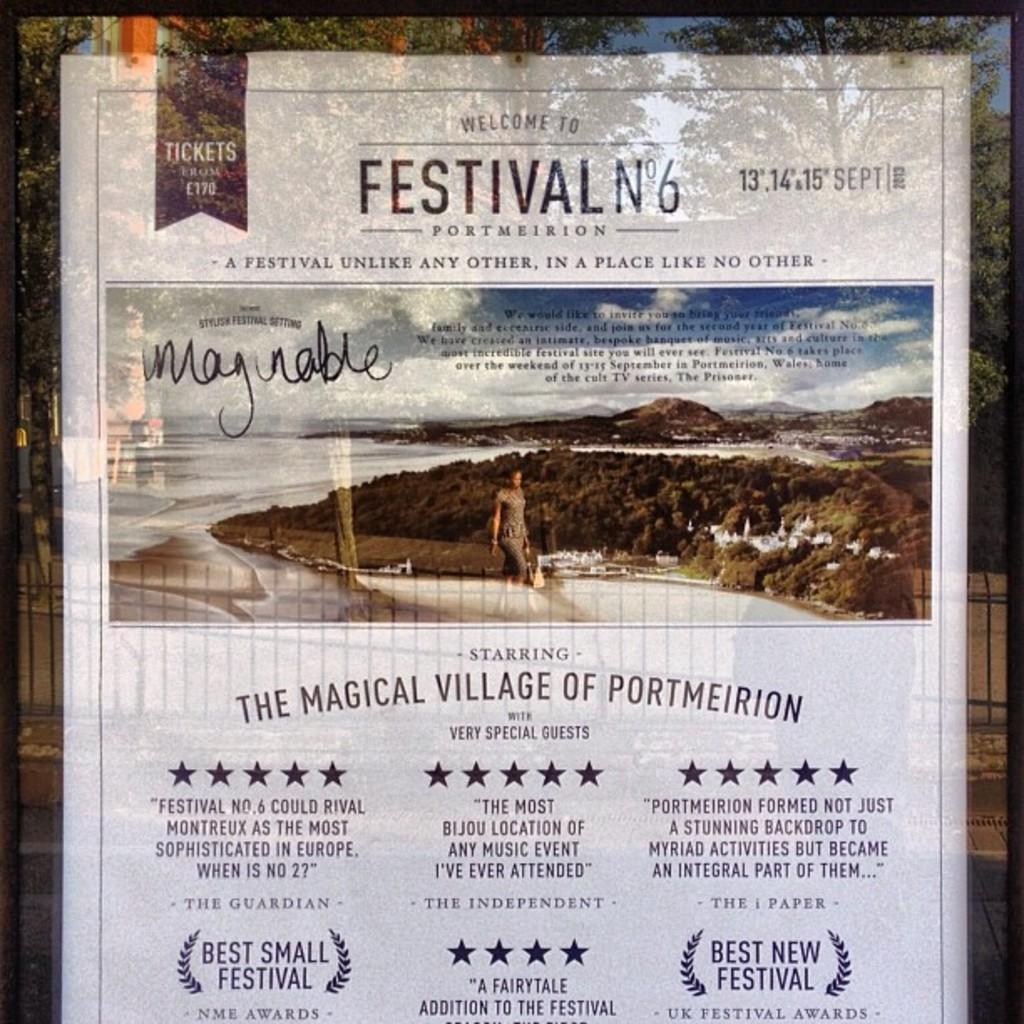<image>
Present a compact description of the photo's key features. A poster welcomes us to Festival No 6 in Portmeirion. 